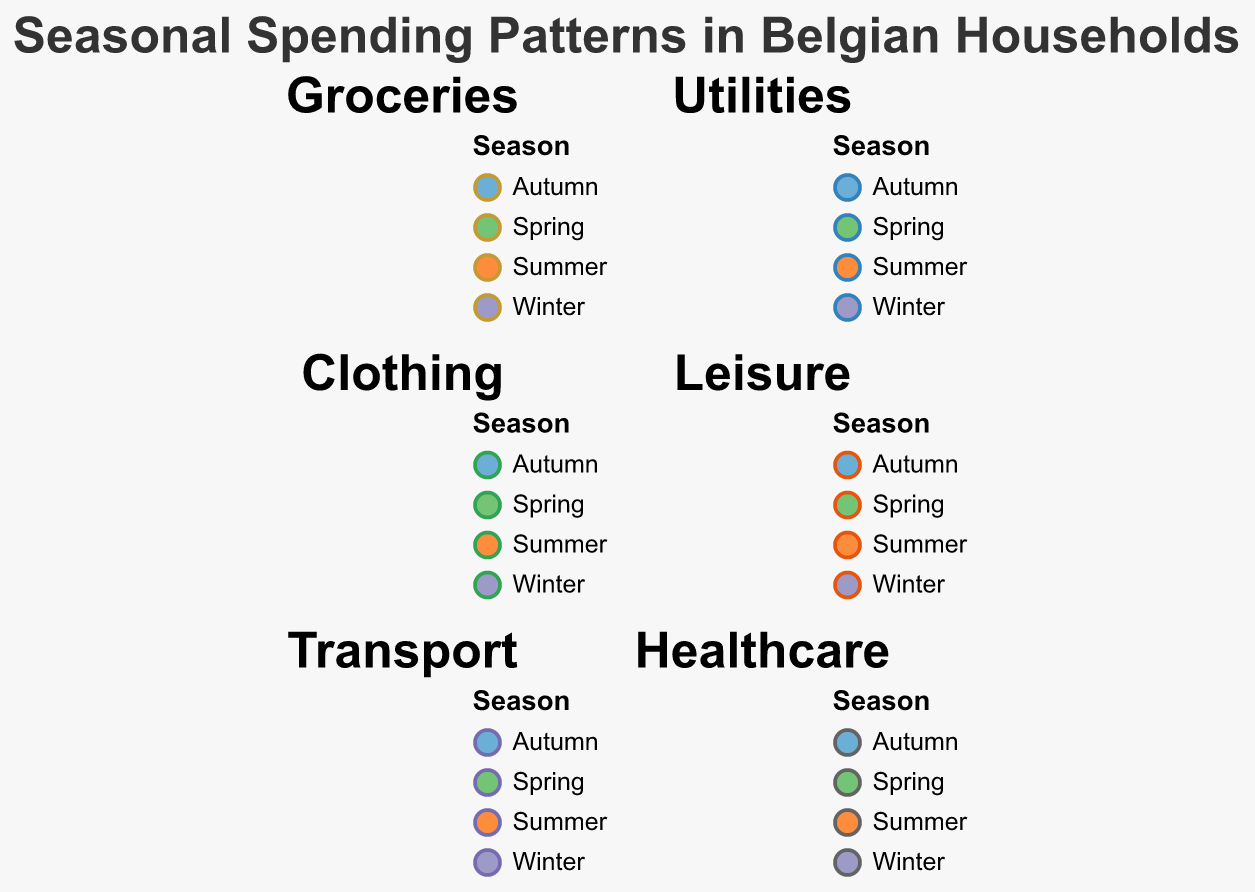How many months are represented in each season? In the figure, each season (Winter, Spring, Summer, Autumn) has three categories (months) represented. Hence, each season has three months depicted.
Answer: Three In which month is the highest spending on groceries observed? By checking each subplot for groceries, the largest radius appears in the category for December within the Autumn season.
Answer: December Which expense category sees the highest spending in Winter for any month? Looking at all subplots for Winter months (January, February, and March), the largest value appears in the Groceries category for January.
Answer: Groceries in January During which season is spending on leisure the highest? Reviewing the radius in the Leisure subplot for each season, the highest spending is observed in Summer in the month of July.
Answer: Summer Compare spending on utilities between January and July. Which month has higher spending? In the Utilities subplot, January (Winter) has a larger radius than July (Summer), indicating higher spending in January.
Answer: January Which season generally has the lowest spending on clothing? By examining the Clothing subplot, the smallest radii are observed in the Summer months (July, August, and September).
Answer: Summer Calculate the total healthcare spending in Spring. Summing up healthcare values for April (105), May (100), and June (95) results in a total spending of 300.
Answer: 300 Which expense category shows the least variation across all seasons? By comparing the radii across all subplots, the Healthcare category seems to have the most consistent spending levels across different months.
Answer: Healthcare In Autumn, which category has the largest difference between the highest and lowest monthly spending? For Autumn (October, November, December), by calculating the differences in spending for each category, the Groceries category (260 in December and 240 in October) shows the largest difference of 20.
Answer: Groceries How does spending on transport in April compare to transport spending in October? In the Transport subplot, the radius for October (Autumn) is higher than that for April (Spring), indicating higher spending in October.
Answer: October 